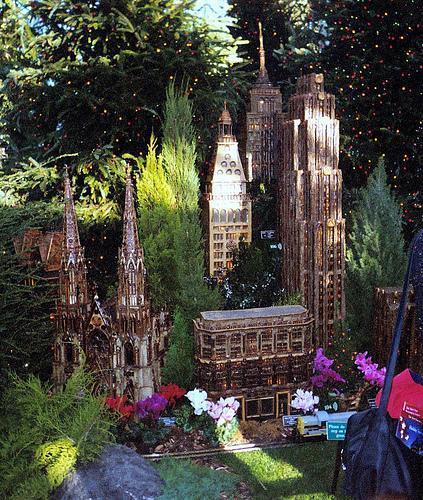How many people are in the photo?
Give a very brief answer. 0. How many rocks are in the photo?
Give a very brief answer. 1. How many structures have a flat roof?
Give a very brief answer. 2. 